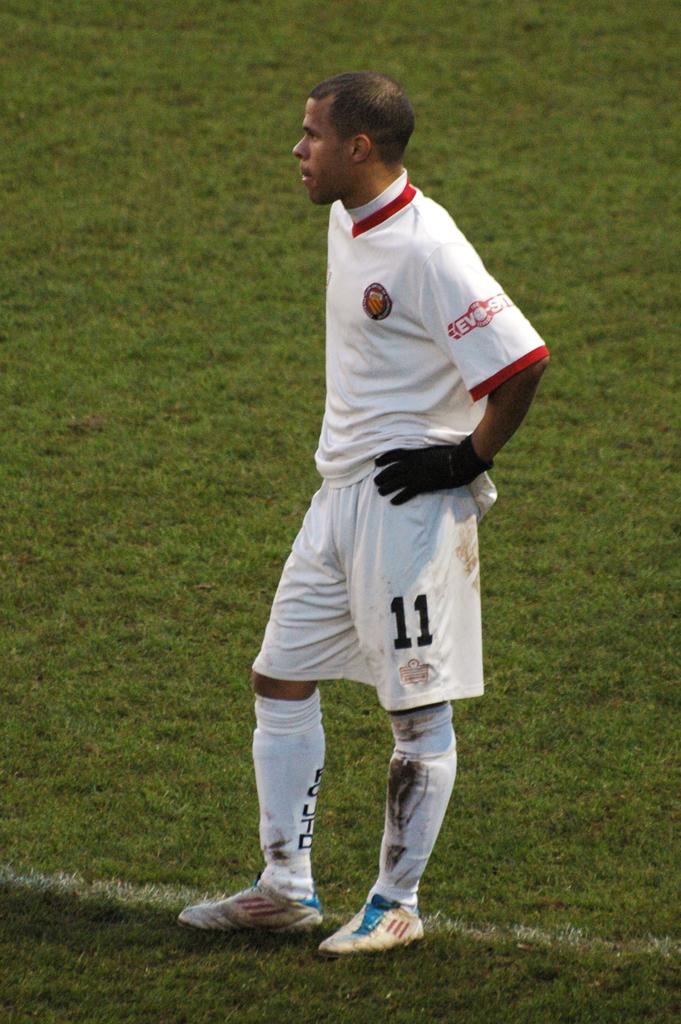The color of the number on the leg is?
Keep it short and to the point. Black. 